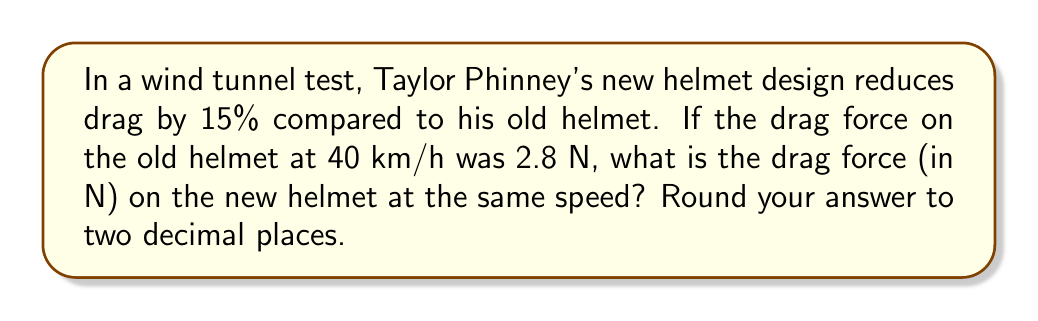Show me your answer to this math problem. Let's approach this step-by-step:

1) First, we need to understand what a 15% reduction means. It means the new drag force is 85% of the old drag force.

2) We can express this mathematically as:
   $F_{new} = 0.85 \times F_{old}$

   Where $F_{new}$ is the drag force of the new helmet and $F_{old}$ is the drag force of the old helmet.

3) We know that $F_{old} = 2.8$ N

4) Now, let's substitute this into our equation:
   $F_{new} = 0.85 \times 2.8$

5) Let's calculate this:
   $F_{new} = 2.38$ N

6) Rounding to two decimal places:
   $F_{new} \approx 2.38$ N

Thus, the drag force on the new helmet at 40 km/h is approximately 2.38 N.
Answer: 2.38 N 